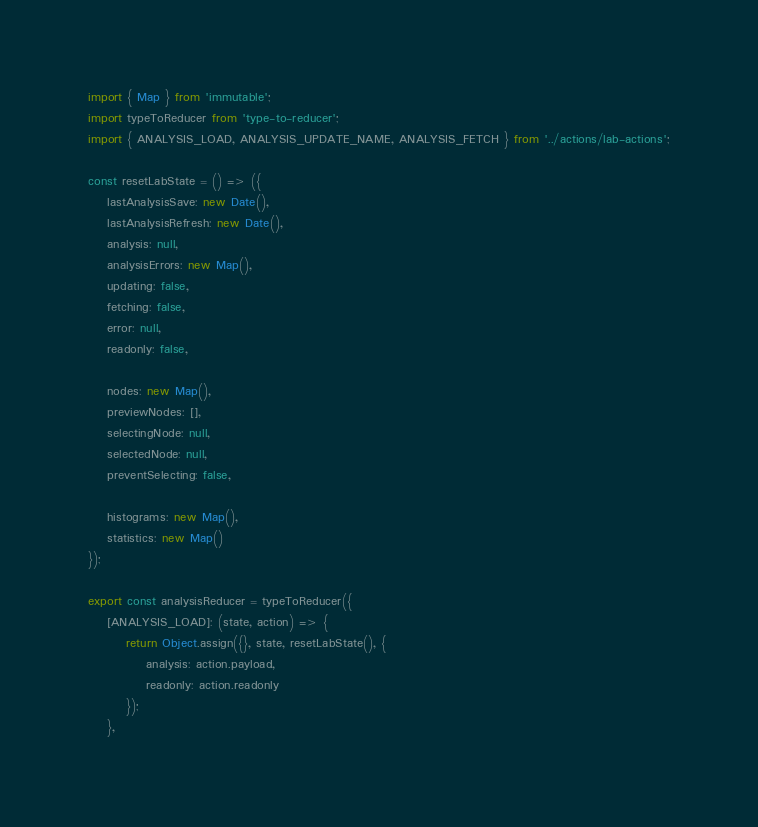Convert code to text. <code><loc_0><loc_0><loc_500><loc_500><_JavaScript_>import { Map } from 'immutable';
import typeToReducer from 'type-to-reducer';
import { ANALYSIS_LOAD, ANALYSIS_UPDATE_NAME, ANALYSIS_FETCH } from '../actions/lab-actions';

const resetLabState = () => ({
    lastAnalysisSave: new Date(),
    lastAnalysisRefresh: new Date(),
    analysis: null,
    analysisErrors: new Map(),
    updating: false,
    fetching: false,
    error: null,
    readonly: false,

    nodes: new Map(),
    previewNodes: [],
    selectingNode: null,
    selectedNode: null,
    preventSelecting: false,

    histograms: new Map(),
    statistics: new Map()
});

export const analysisReducer = typeToReducer({
    [ANALYSIS_LOAD]: (state, action) => {
        return Object.assign({}, state, resetLabState(), {
            analysis: action.payload,
            readonly: action.readonly
        });
    },</code> 